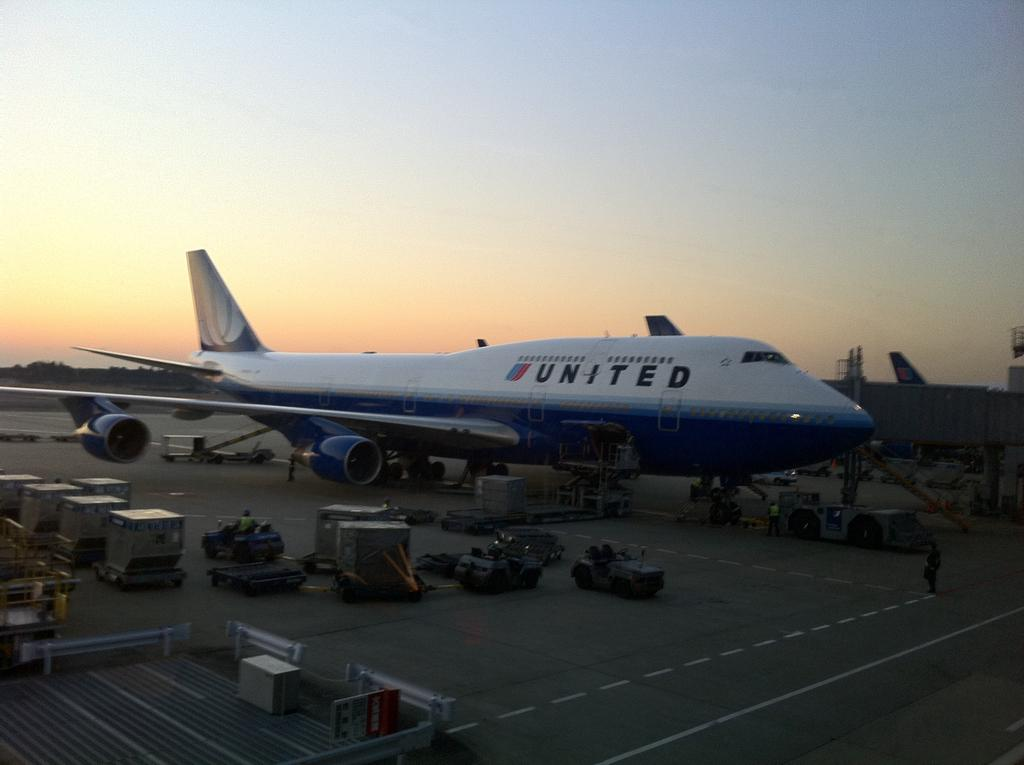<image>
Write a terse but informative summary of the picture. United plane that is on land is surrounded around people 